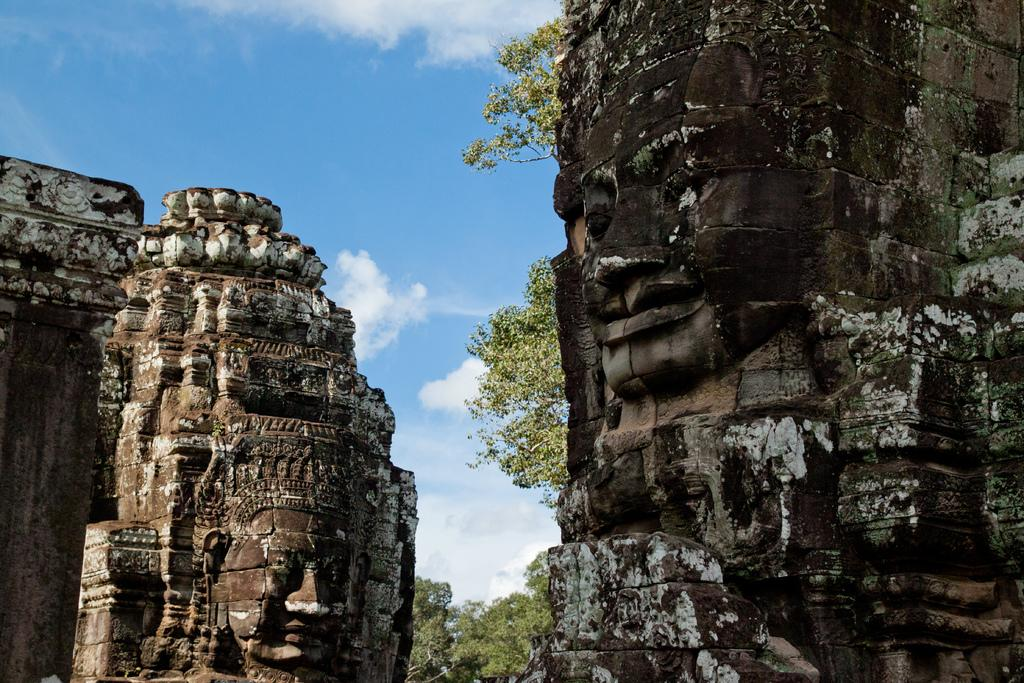What can be seen in the front of the image? There are sculptures in the front of the image. What type of natural elements are visible in the background of the image? There are trees in the background of the image. What is visible in the sky in the background of the image? The sky is visible in the background of the image. Can you tell me how many stalks of celery are depicted in the image? There are no stalks of celery present in the image. How does the disgust in the image manifest itself? There is no indication of disgust in the image; it features sculptures and trees. 